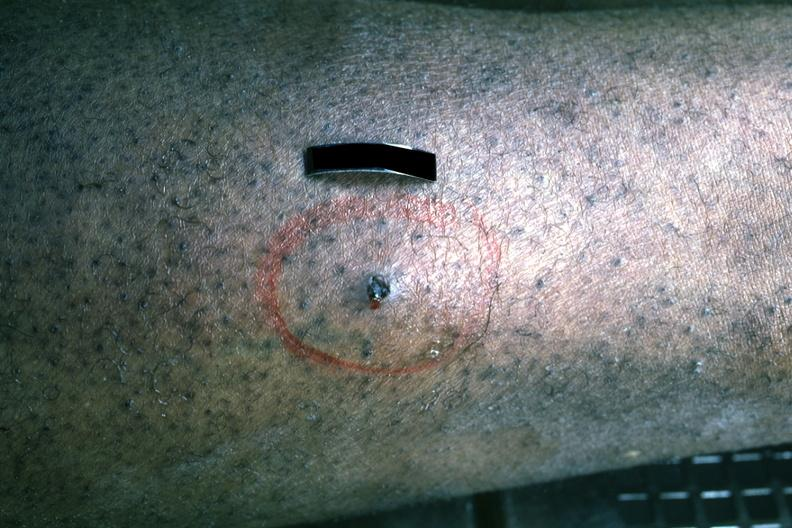what is present?
Answer the question using a single word or phrase. Bullet wound 